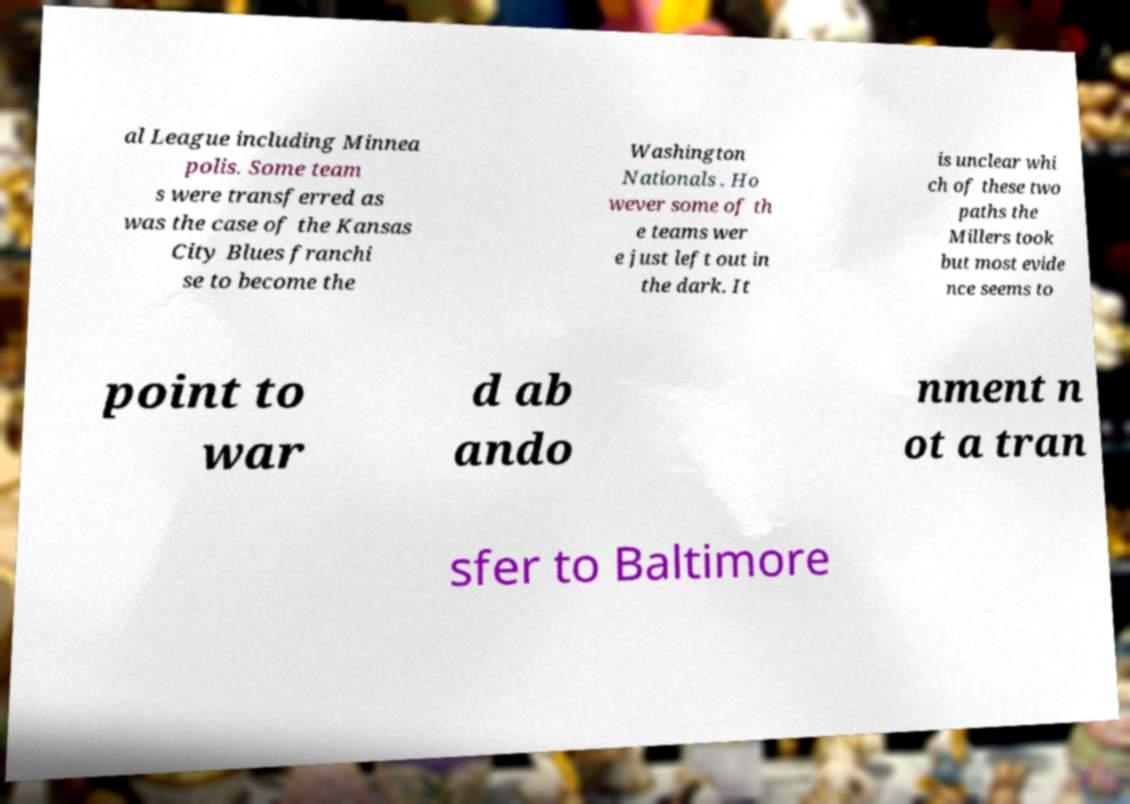For documentation purposes, I need the text within this image transcribed. Could you provide that? al League including Minnea polis. Some team s were transferred as was the case of the Kansas City Blues franchi se to become the Washington Nationals . Ho wever some of th e teams wer e just left out in the dark. It is unclear whi ch of these two paths the Millers took but most evide nce seems to point to war d ab ando nment n ot a tran sfer to Baltimore 